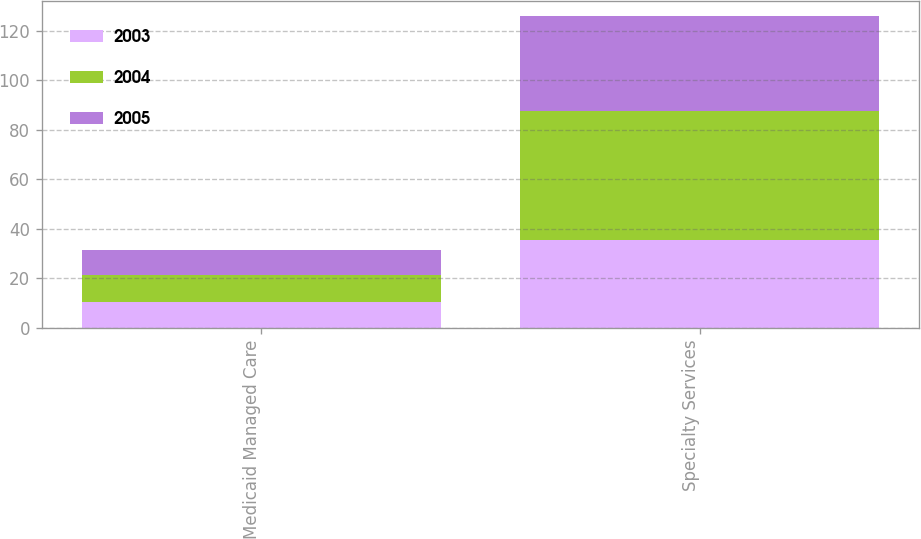<chart> <loc_0><loc_0><loc_500><loc_500><stacked_bar_chart><ecel><fcel>Medicaid Managed Care<fcel>Specialty Services<nl><fcel>2003<fcel>10.5<fcel>35.4<nl><fcel>2004<fcel>10.7<fcel>52.3<nl><fcel>2005<fcel>10.3<fcel>38.2<nl></chart> 